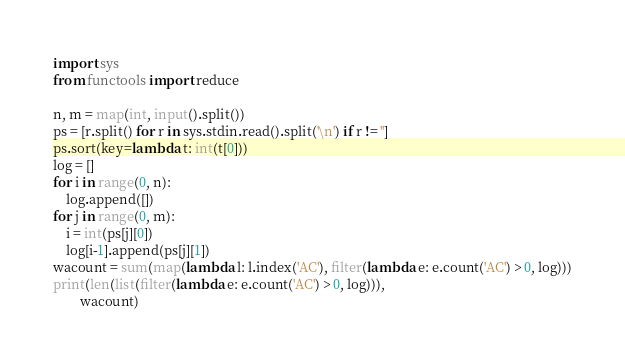<code> <loc_0><loc_0><loc_500><loc_500><_Python_>import sys
from functools import reduce

n, m = map(int, input().split())
ps = [r.split() for r in sys.stdin.read().split('\n') if r != '']
ps.sort(key=lambda t: int(t[0]))
log = []
for i in range(0, n):
    log.append([])
for j in range(0, m):
    i = int(ps[j][0])
    log[i-1].append(ps[j][1])
wacount = sum(map(lambda l: l.index('AC'), filter(lambda e: e.count('AC') > 0, log)))
print(len(list(filter(lambda e: e.count('AC') > 0, log))),
        wacount)</code> 